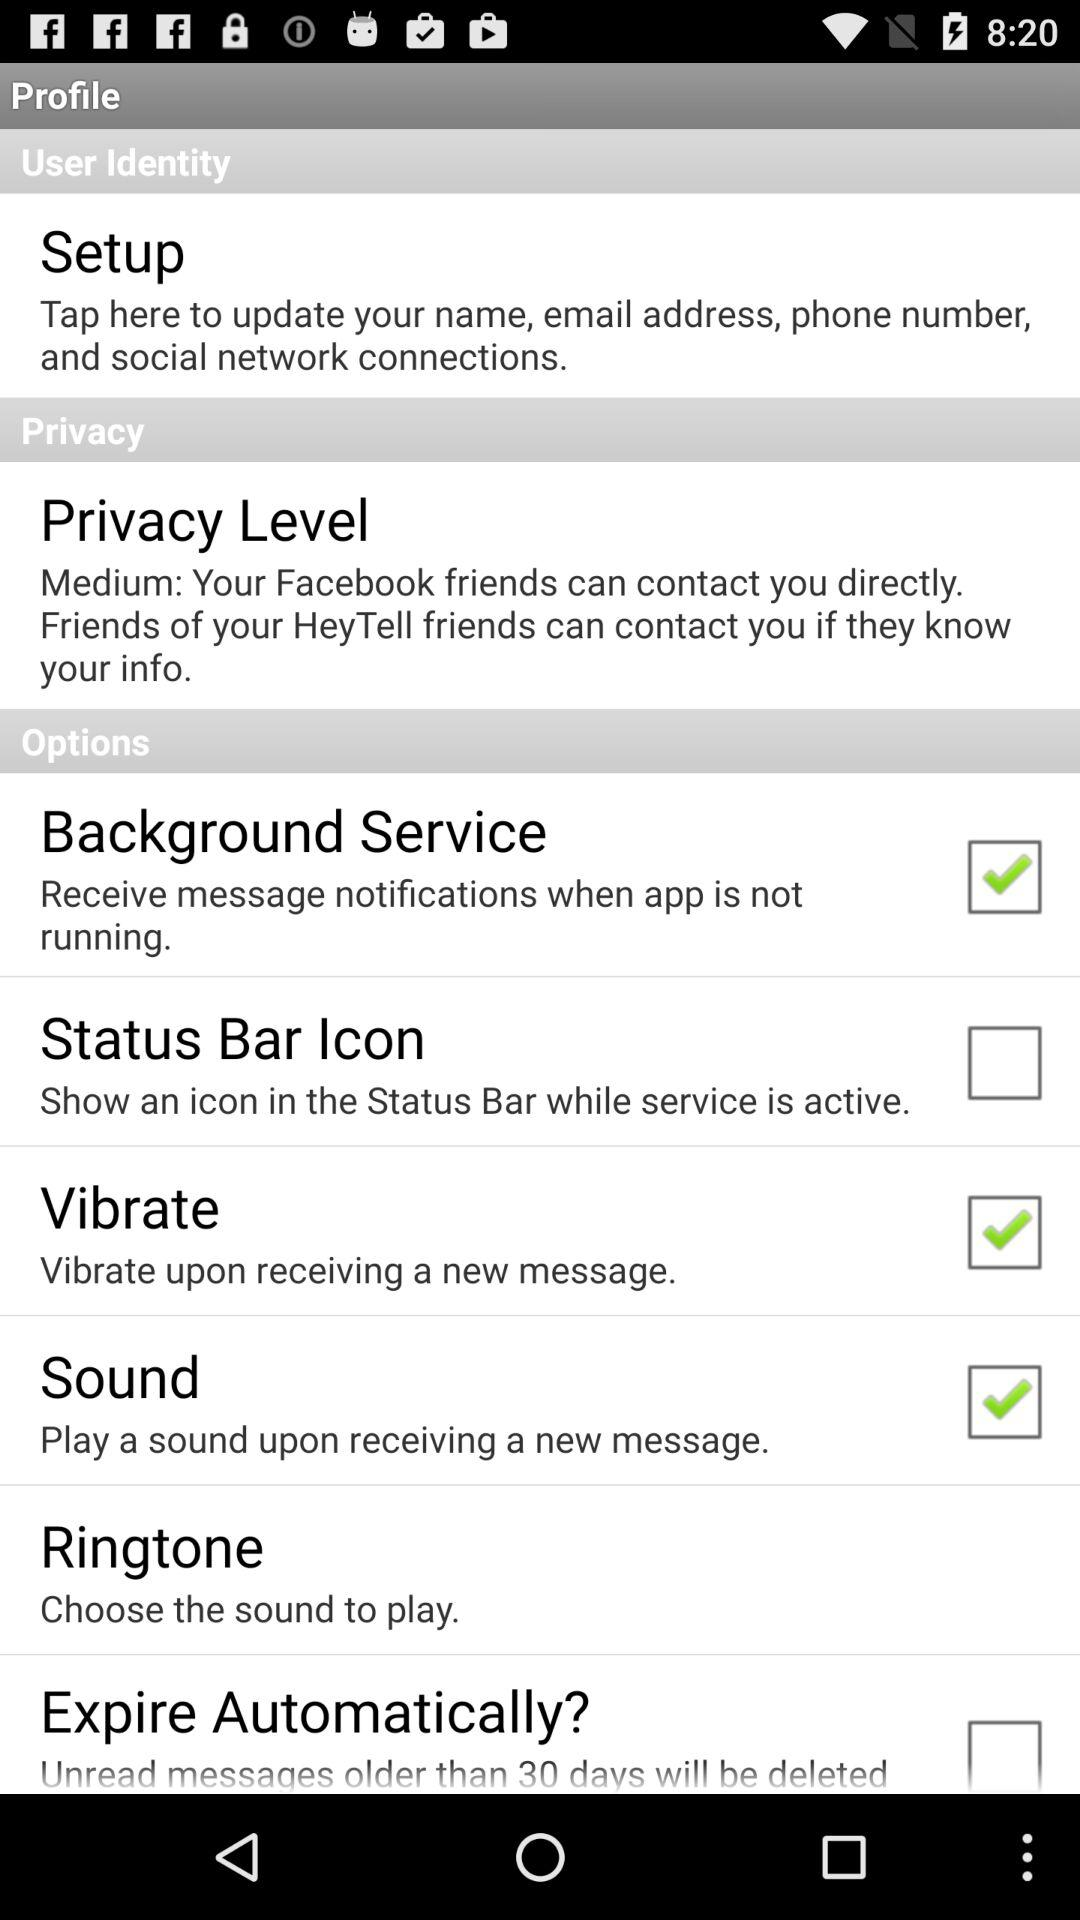Is the "Vibrate" option checked or unchecked? The "Vibrate" option is checked. 